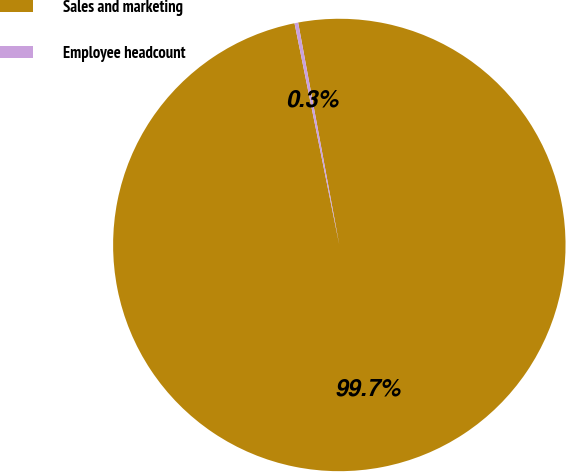<chart> <loc_0><loc_0><loc_500><loc_500><pie_chart><fcel>Sales and marketing<fcel>Employee headcount<nl><fcel>99.74%<fcel>0.26%<nl></chart> 